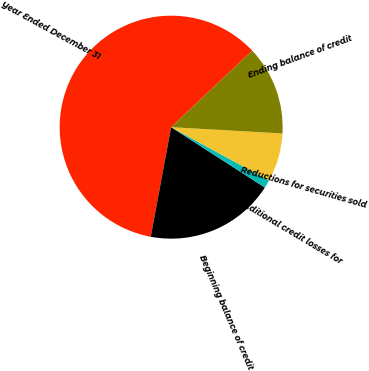Convert chart to OTSL. <chart><loc_0><loc_0><loc_500><loc_500><pie_chart><fcel>Year Ended December 31<fcel>Beginning balance of credit<fcel>Additional credit losses for<fcel>Reductions for securities sold<fcel>Ending balance of credit<nl><fcel>60.03%<fcel>18.82%<fcel>1.16%<fcel>7.05%<fcel>12.94%<nl></chart> 